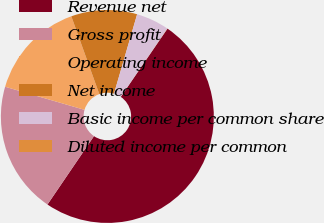Convert chart. <chart><loc_0><loc_0><loc_500><loc_500><pie_chart><fcel>Revenue net<fcel>Gross profit<fcel>Operating income<fcel>Net income<fcel>Basic income per common share<fcel>Diluted income per common<nl><fcel>49.96%<fcel>20.0%<fcel>15.0%<fcel>10.01%<fcel>5.02%<fcel>0.02%<nl></chart> 